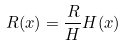Convert formula to latex. <formula><loc_0><loc_0><loc_500><loc_500>R ( x ) = \frac { R } { H } H ( x )</formula> 